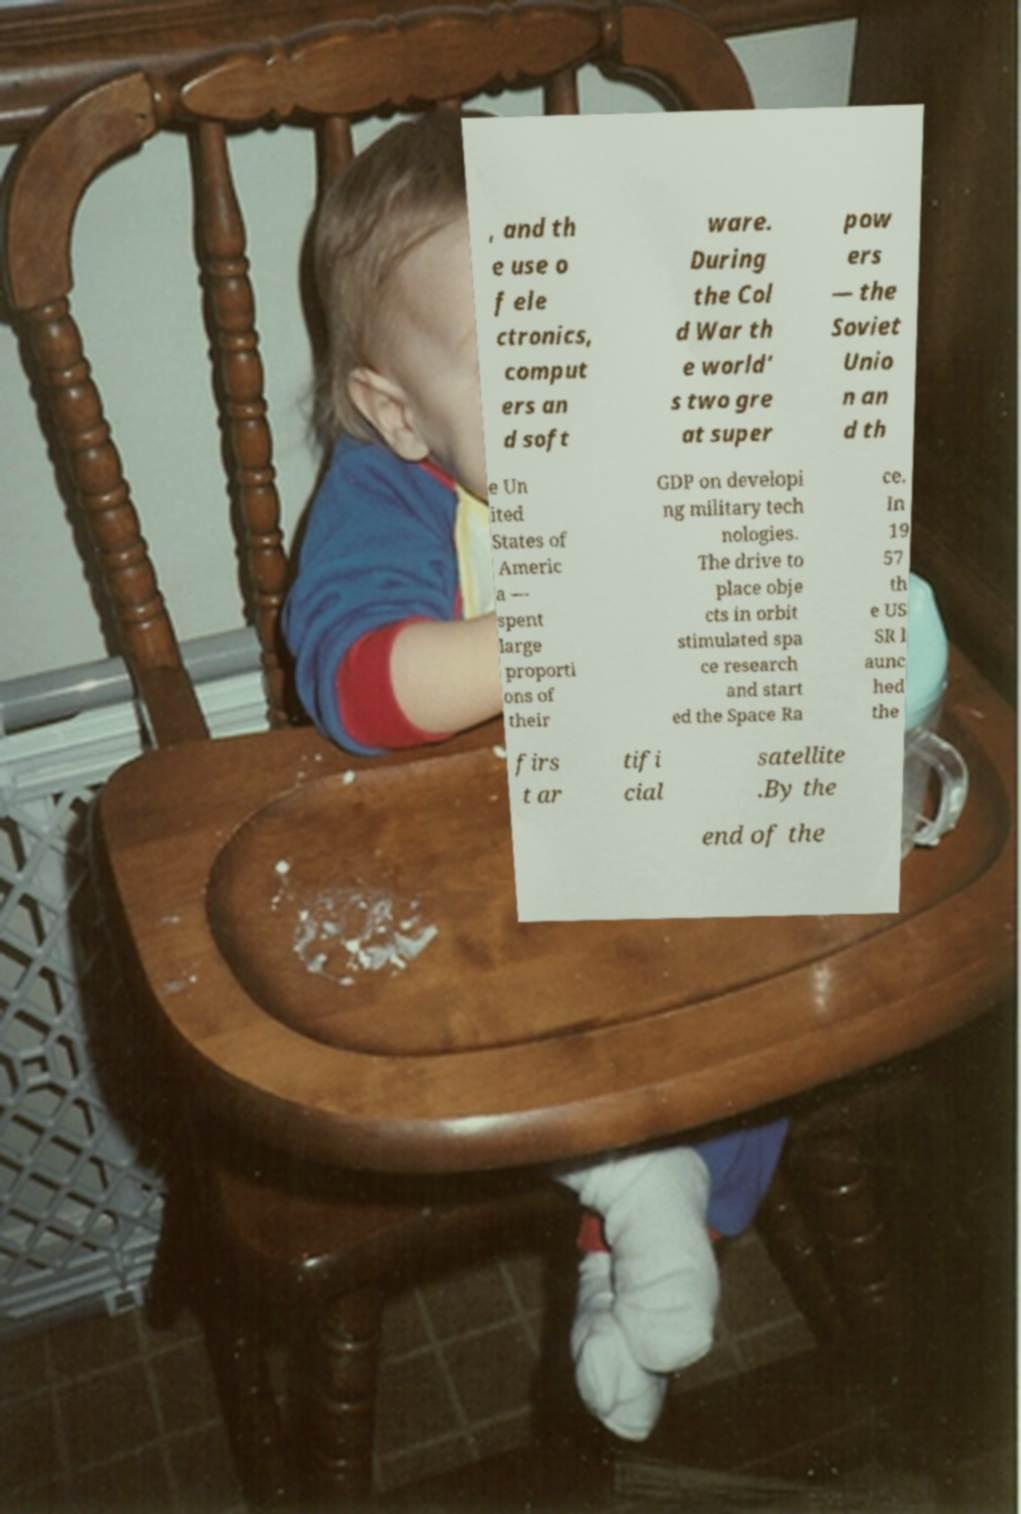For documentation purposes, I need the text within this image transcribed. Could you provide that? , and th e use o f ele ctronics, comput ers an d soft ware. During the Col d War th e world' s two gre at super pow ers — the Soviet Unio n an d th e Un ited States of Americ a — spent large proporti ons of their GDP on developi ng military tech nologies. The drive to place obje cts in orbit stimulated spa ce research and start ed the Space Ra ce. In 19 57 th e US SR l aunc hed the firs t ar tifi cial satellite .By the end of the 